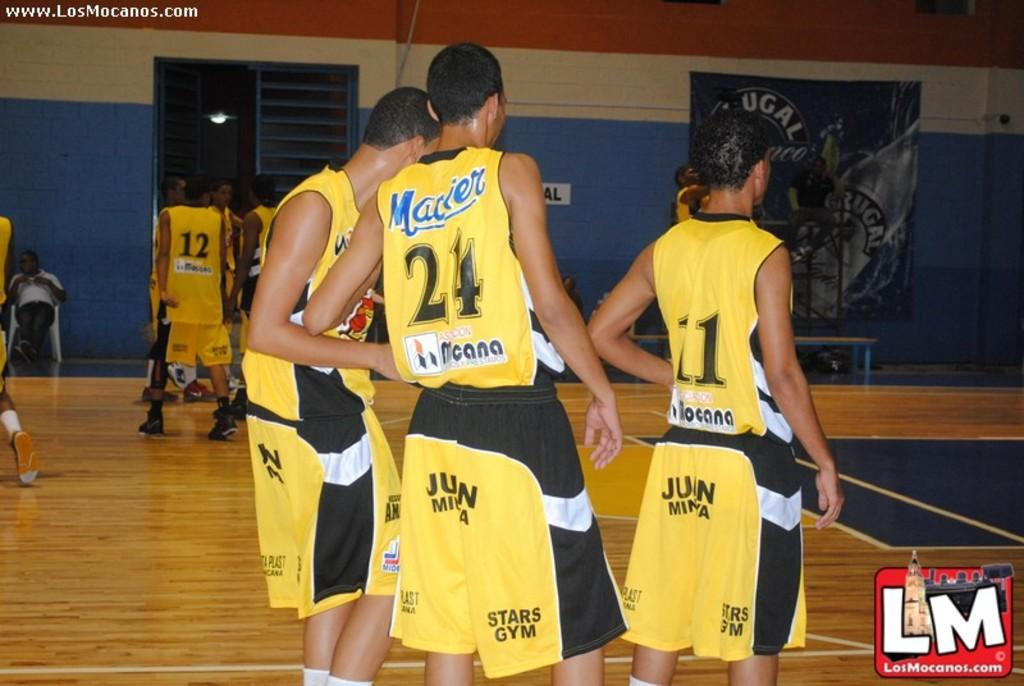<image>
Provide a brief description of the given image. a few players with one wearing 24 on the basketball court 